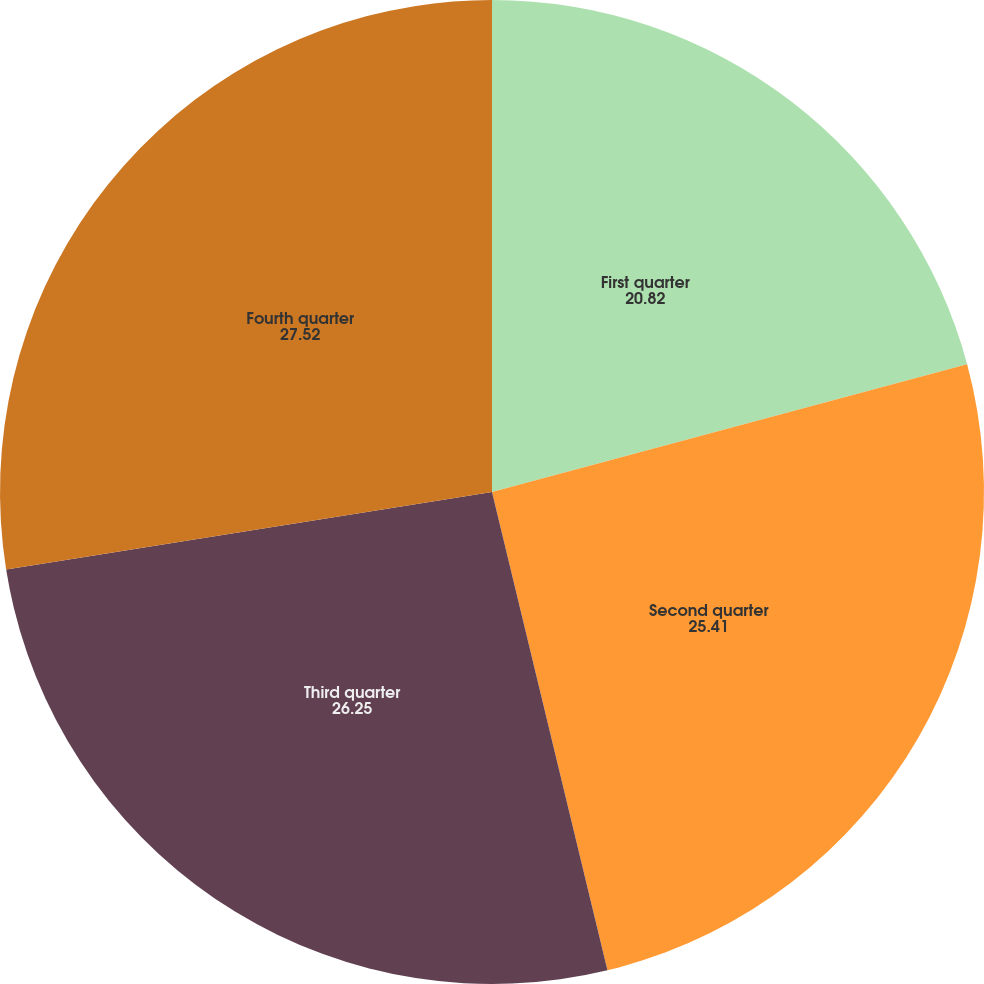<chart> <loc_0><loc_0><loc_500><loc_500><pie_chart><fcel>First quarter<fcel>Second quarter<fcel>Third quarter<fcel>Fourth quarter<nl><fcel>20.82%<fcel>25.41%<fcel>26.25%<fcel>27.52%<nl></chart> 